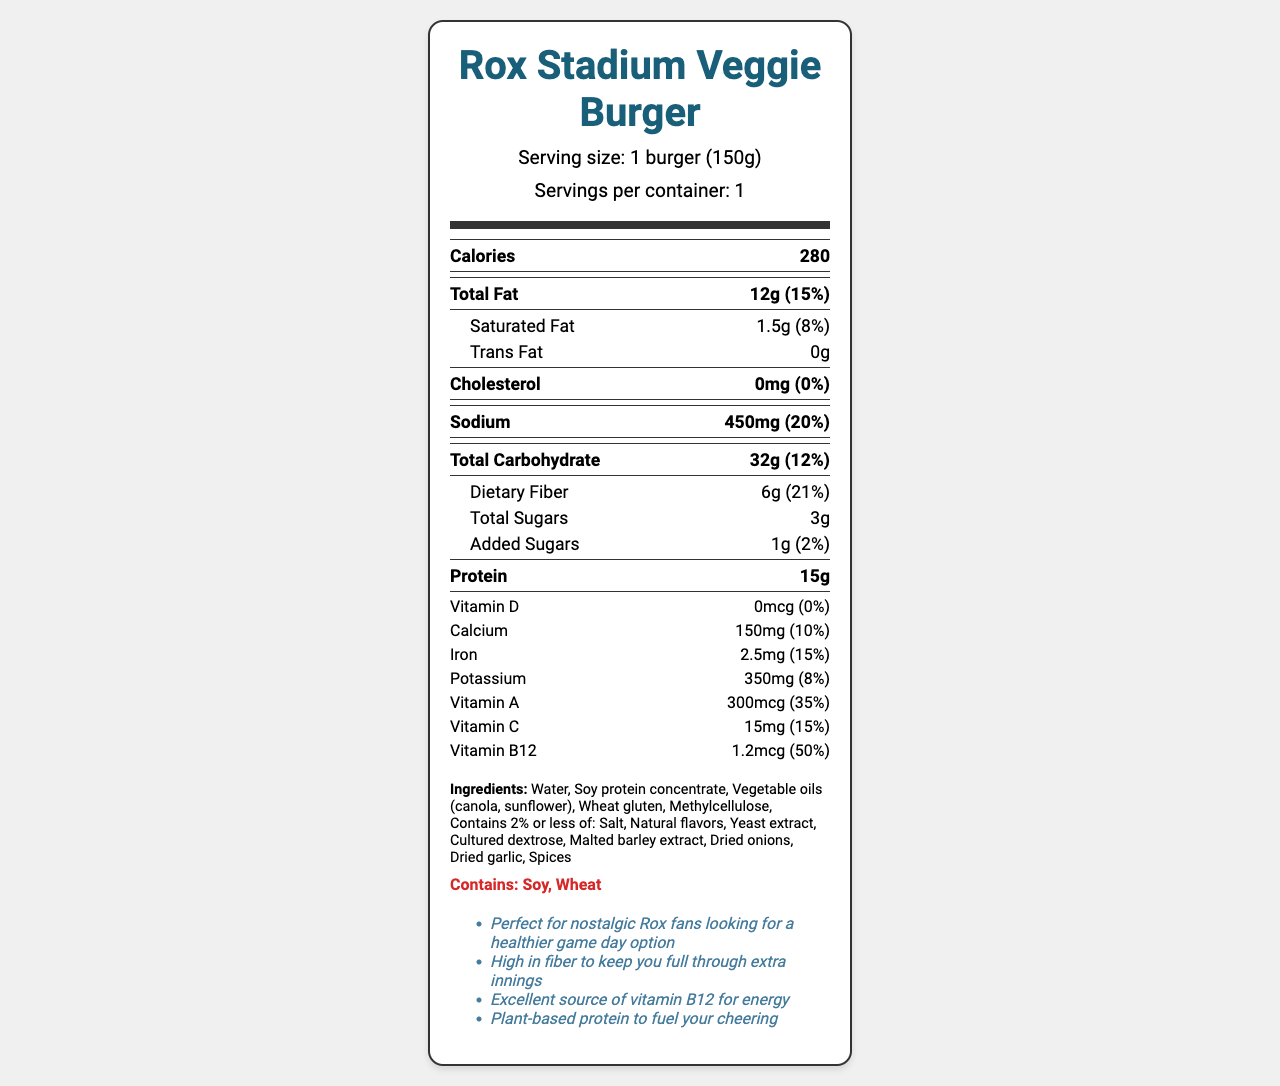what is the serving size of the Rox Stadium Veggie Burger? The serving size is listed right below the product name in the document.
Answer: 1 burger (150g) how many calories does one Rox Stadium Veggie Burger contain? The calorie count is prominently listed as "Calories 280" in the document.
Answer: 280 what are the allergenic ingredients in this veggie burger? The allergens section explicitly states "Contains: Soy, Wheat."
Answer: Soy, Wheat what is the percentage of daily value for dietary fiber in this burger? The daily value percentage for dietary fiber is given as "21%" in the dietary fiber section.
Answer: 21% how much protein does the veggie burger provide per serving? The protein amount per serving is listed as "15g" in the nutrition facts.
Answer: 15g which vitamin is provided in the highest daily value percentage? The daily value for Vitamin B12 is 50%, which is the highest among the listed vitamins.
Answer: Vitamin B12 what additional benefit does the burger provide related to energy? The additional info section mentions that it is an "Excellent source of vitamin B12 for energy."
Answer: Excellent source of vitamin B12 what is the total carbohydrate content in the veggie burger? A. 20g B. 25g C. 32g D. 35g The total carbohydrate content is listed as "32g."
Answer: C. 32g how much saturated fat does this burger contain? A. 0.5g B. 1.5g C. 2g D. 3g The saturated fat content is listed as "1.5g."
Answer: B. 1.5g does the veggie burger contain any cholesterol? The document lists "Cholesterol 0mg (0%)" indicating there is no cholesterol in the burger.
Answer: No is the Rox Stadium Veggie Burger a good source of vitamin C? The document states that it provides 15% of the daily value for vitamin C, which is a notable percentage.
Answer: Yes can you determine whether the protein in the burger is animal-based or plant-based purely from the ingredients list? The ingredients list includes soy protein concentrate and various vegetable oils, indicating plant-based protein.
Answer: Yes, it's plant-based. describe the main nutritional benefits of the Rox Stadium Veggie Burger. These benefits are detailed by combining information from various sections of the document, including fiber content, protein source, and vitamin and mineral daily values.
Answer: The Rox Stadium Veggie Burger is a high-fiber, plant-based option that provides a notable amount of protein (15g), is low in saturated fat, contains no cholesterol, and is an excellent source of Vitamin B12 and Vitamin A. It also contains beneficial levels of other vitamins and minerals like Calcium, Iron, Potassium, and Vitamin C. what is the background image of the document? The information about the background image is not visually present on the document itself. Therefore, it cannot be determined.
Answer: Cannot be determined 